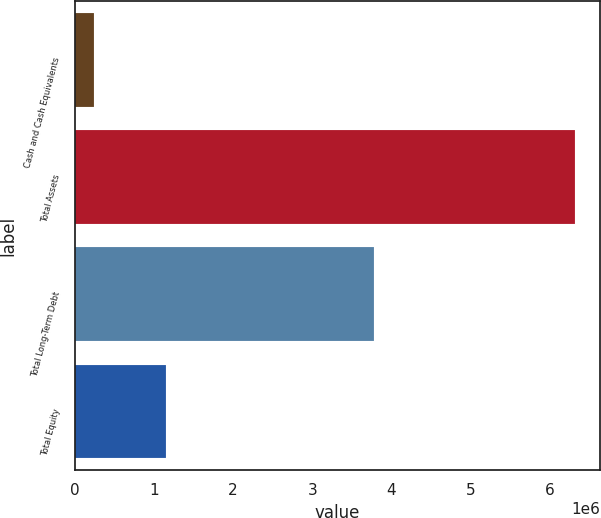Convert chart. <chart><loc_0><loc_0><loc_500><loc_500><bar_chart><fcel>Cash and Cash Equivalents<fcel>Total Assets<fcel>Total Long-Term Debt<fcel>Total Equity<nl><fcel>243415<fcel>6.31449e+06<fcel>3.78115e+06<fcel>1.15715e+06<nl></chart> 